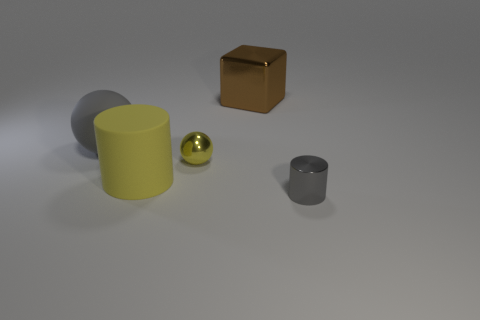Subtract all cyan blocks. Subtract all green balls. How many blocks are left? 1 Add 3 big things. How many objects exist? 8 Subtract all balls. How many objects are left? 3 Subtract 0 blue blocks. How many objects are left? 5 Subtract all small cylinders. Subtract all brown things. How many objects are left? 3 Add 1 big gray things. How many big gray things are left? 2 Add 4 tiny green matte balls. How many tiny green matte balls exist? 4 